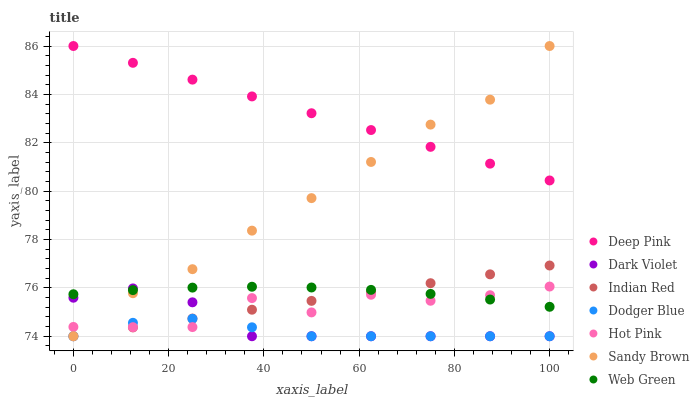Does Dodger Blue have the minimum area under the curve?
Answer yes or no. Yes. Does Deep Pink have the maximum area under the curve?
Answer yes or no. Yes. Does Hot Pink have the minimum area under the curve?
Answer yes or no. No. Does Hot Pink have the maximum area under the curve?
Answer yes or no. No. Is Indian Red the smoothest?
Answer yes or no. Yes. Is Hot Pink the roughest?
Answer yes or no. Yes. Is Dark Violet the smoothest?
Answer yes or no. No. Is Dark Violet the roughest?
Answer yes or no. No. Does Dark Violet have the lowest value?
Answer yes or no. Yes. Does Hot Pink have the lowest value?
Answer yes or no. No. Does Sandy Brown have the highest value?
Answer yes or no. Yes. Does Hot Pink have the highest value?
Answer yes or no. No. Is Web Green less than Deep Pink?
Answer yes or no. Yes. Is Deep Pink greater than Dark Violet?
Answer yes or no. Yes. Does Indian Red intersect Dark Violet?
Answer yes or no. Yes. Is Indian Red less than Dark Violet?
Answer yes or no. No. Is Indian Red greater than Dark Violet?
Answer yes or no. No. Does Web Green intersect Deep Pink?
Answer yes or no. No. 